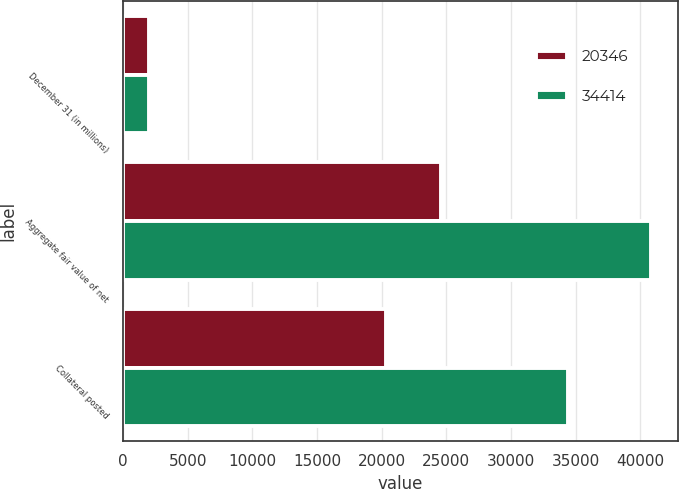<chart> <loc_0><loc_0><loc_500><loc_500><stacked_bar_chart><ecel><fcel>December 31 (in millions)<fcel>Aggregate fair value of net<fcel>Collateral posted<nl><fcel>20346<fcel>2013<fcel>24631<fcel>20346<nl><fcel>34414<fcel>2012<fcel>40844<fcel>34414<nl></chart> 